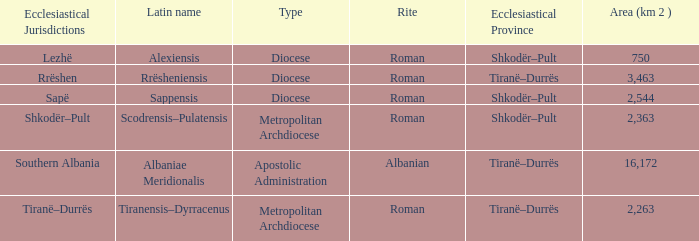Can you explain the meaning of type for rite albanian? Apostolic Administration. 